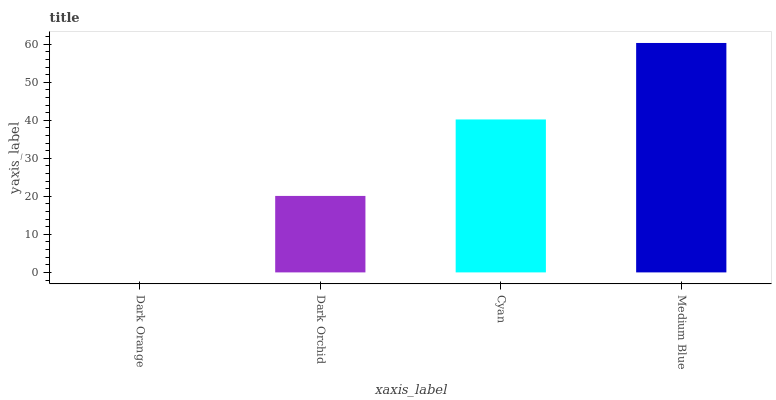Is Dark Orange the minimum?
Answer yes or no. Yes. Is Medium Blue the maximum?
Answer yes or no. Yes. Is Dark Orchid the minimum?
Answer yes or no. No. Is Dark Orchid the maximum?
Answer yes or no. No. Is Dark Orchid greater than Dark Orange?
Answer yes or no. Yes. Is Dark Orange less than Dark Orchid?
Answer yes or no. Yes. Is Dark Orange greater than Dark Orchid?
Answer yes or no. No. Is Dark Orchid less than Dark Orange?
Answer yes or no. No. Is Cyan the high median?
Answer yes or no. Yes. Is Dark Orchid the low median?
Answer yes or no. Yes. Is Dark Orange the high median?
Answer yes or no. No. Is Cyan the low median?
Answer yes or no. No. 